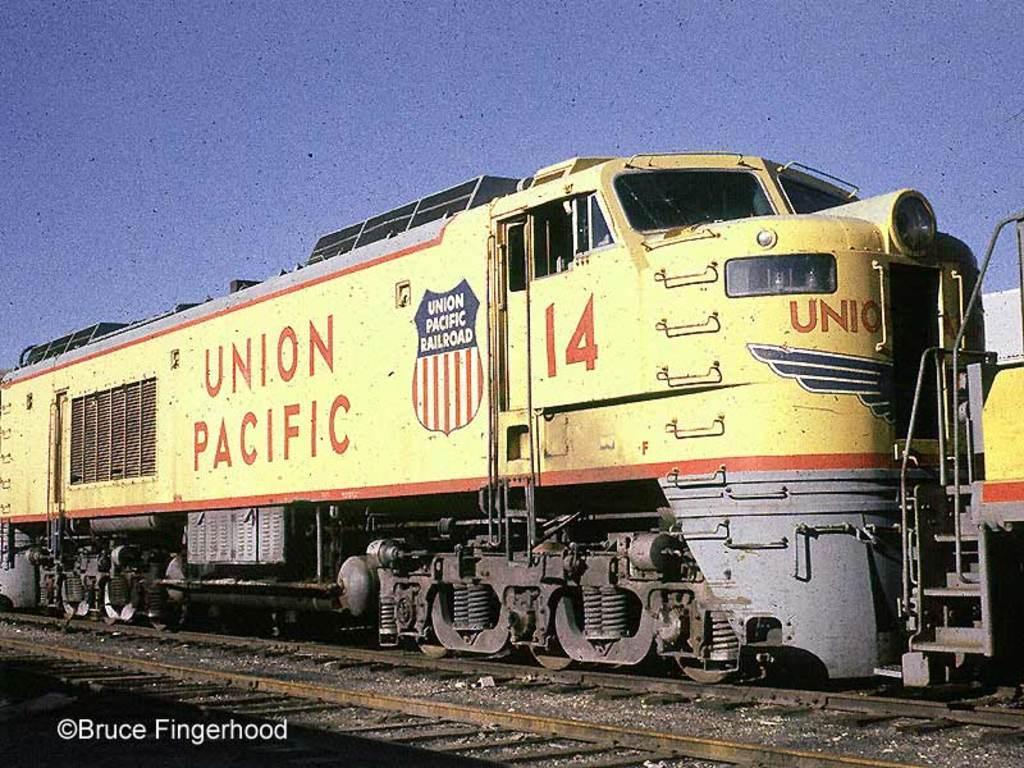In one or two sentences, can you explain what this image depicts? In this image there is a train on the railway track. In the background of the image there is sky. There is some text at the bottom of the image. 